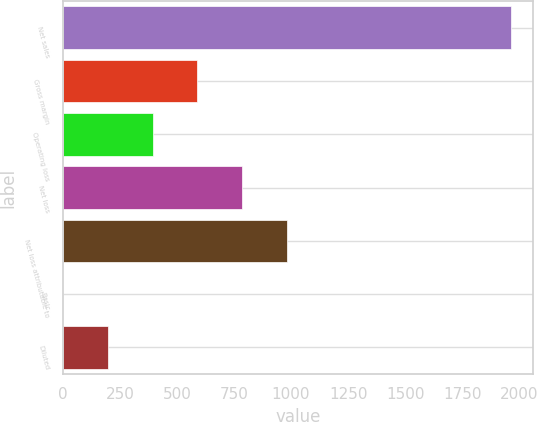Convert chart to OTSL. <chart><loc_0><loc_0><loc_500><loc_500><bar_chart><fcel>Net sales<fcel>Gross margin<fcel>Operating loss<fcel>Net loss<fcel>Net loss attributable to<fcel>Basic<fcel>Diluted<nl><fcel>1963<fcel>589.08<fcel>392.8<fcel>785.36<fcel>981.64<fcel>0.24<fcel>196.52<nl></chart> 